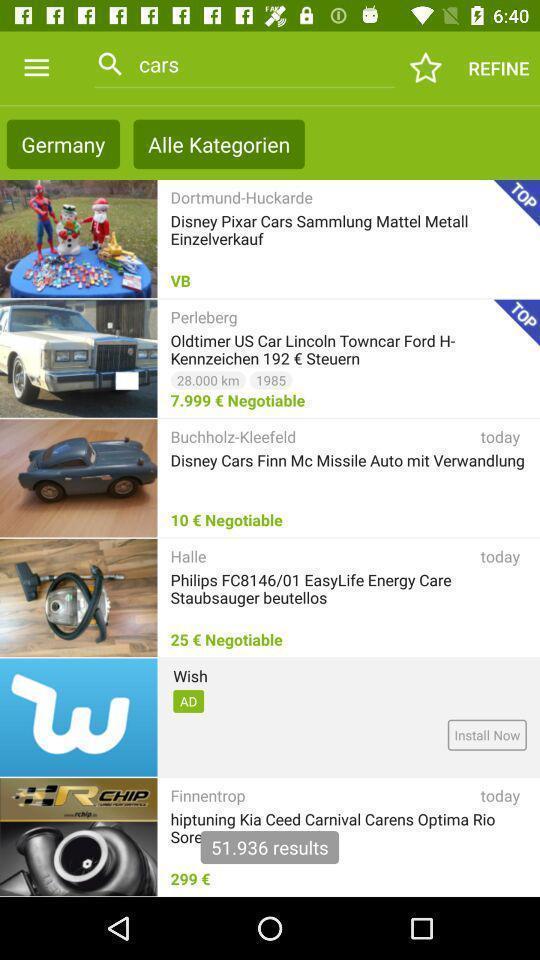Summarize the information in this screenshot. Page displaying various options about car. 